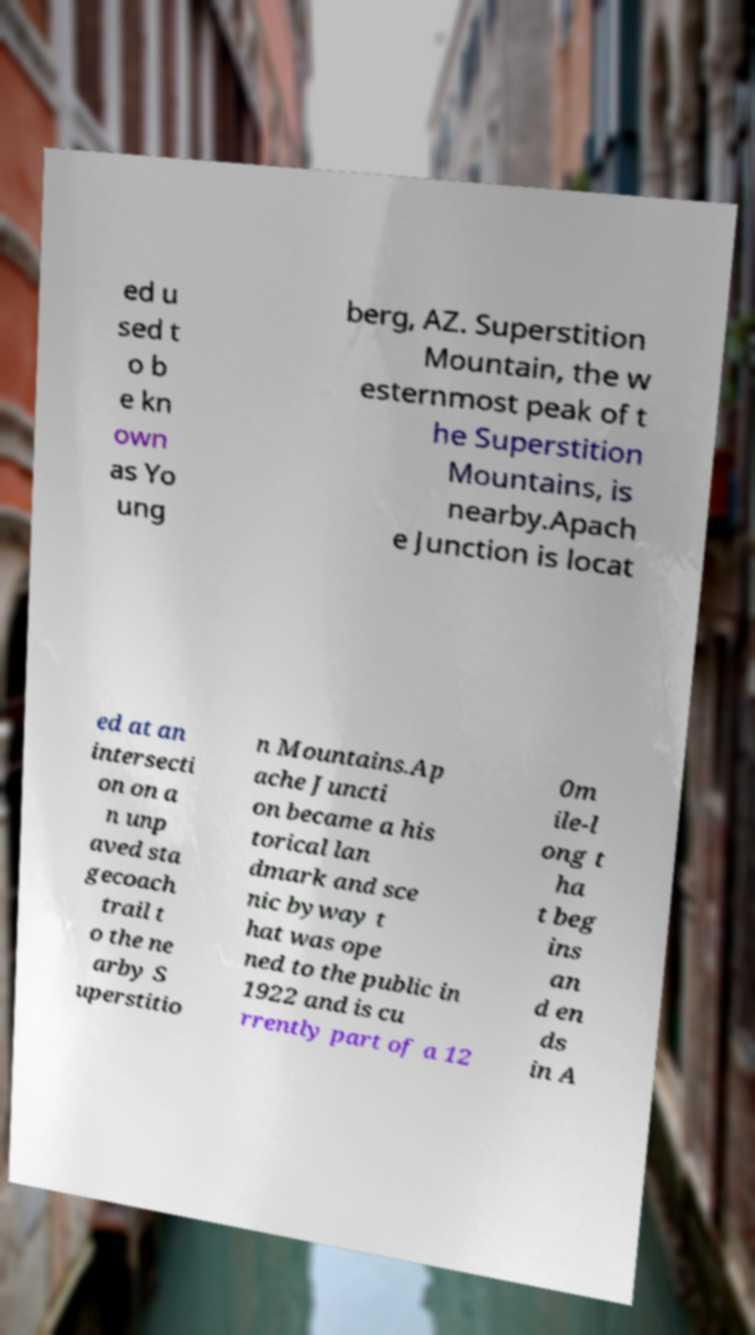I need the written content from this picture converted into text. Can you do that? ed u sed t o b e kn own as Yo ung berg, AZ. Superstition Mountain, the w esternmost peak of t he Superstition Mountains, is nearby.Apach e Junction is locat ed at an intersecti on on a n unp aved sta gecoach trail t o the ne arby S uperstitio n Mountains.Ap ache Juncti on became a his torical lan dmark and sce nic byway t hat was ope ned to the public in 1922 and is cu rrently part of a 12 0m ile-l ong t ha t beg ins an d en ds in A 